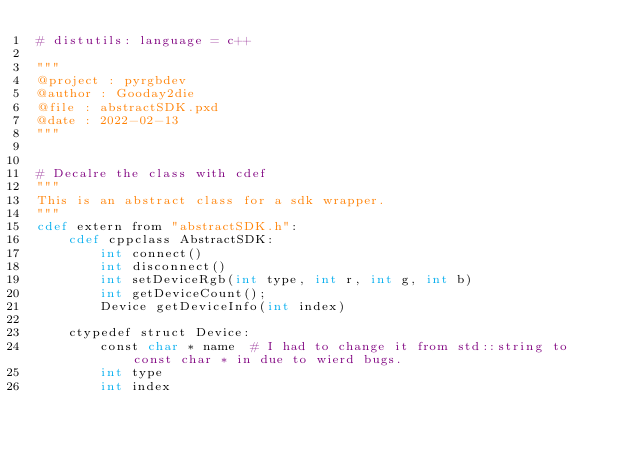Convert code to text. <code><loc_0><loc_0><loc_500><loc_500><_Cython_># distutils: language = c++

"""
@project : pyrgbdev
@author : Gooday2die
@file : abstractSDK.pxd
@date : 2022-02-13
"""


# Decalre the class with cdef
"""
This is an abstract class for a sdk wrapper.
"""
cdef extern from "abstractSDK.h":
    cdef cppclass AbstractSDK:
        int connect()
        int disconnect()
        int setDeviceRgb(int type, int r, int g, int b)
        int getDeviceCount();
        Device getDeviceInfo(int index)

    ctypedef struct Device:
        const char * name  # I had to change it from std::string to const char * in due to wierd bugs.
        int type
        int index</code> 